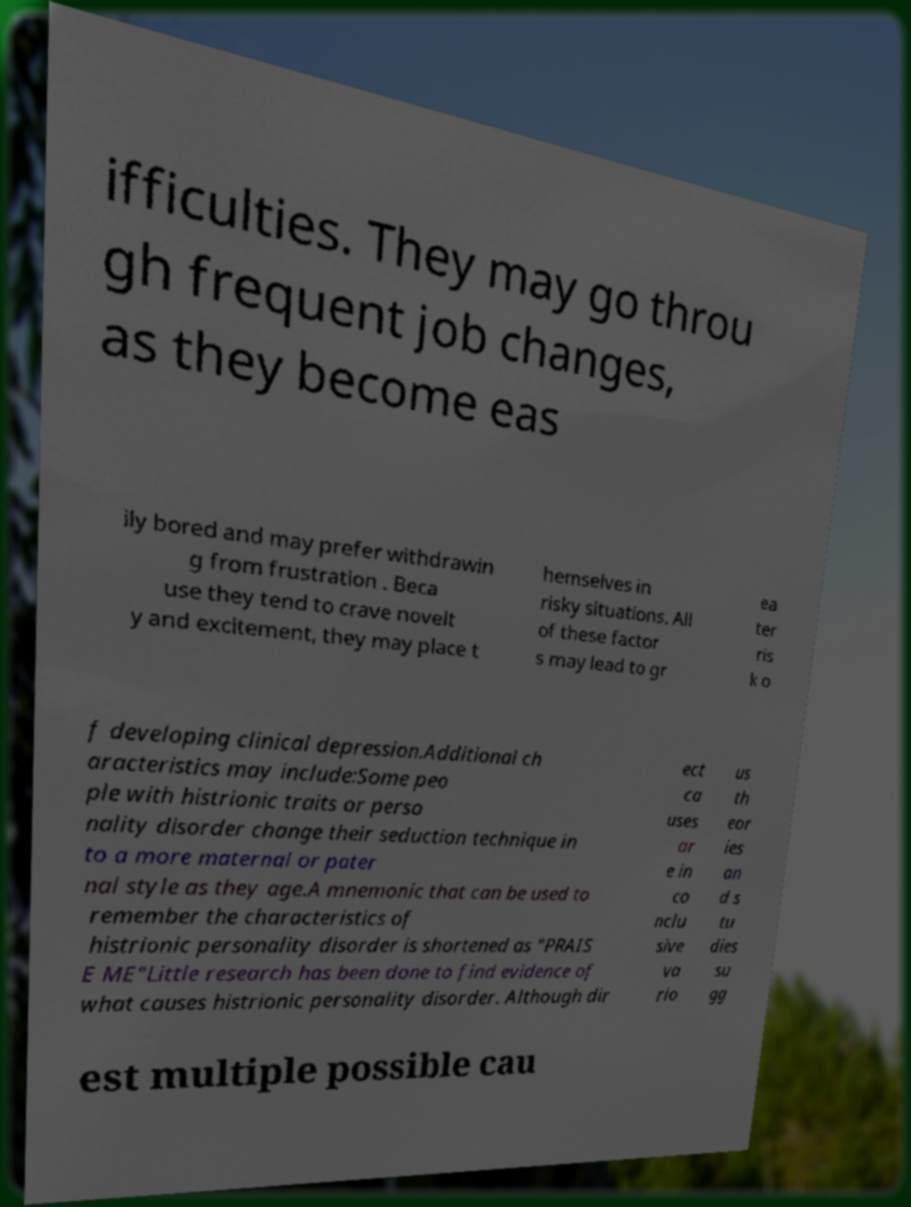Can you read and provide the text displayed in the image?This photo seems to have some interesting text. Can you extract and type it out for me? ifficulties. They may go throu gh frequent job changes, as they become eas ily bored and may prefer withdrawin g from frustration . Beca use they tend to crave novelt y and excitement, they may place t hemselves in risky situations. All of these factor s may lead to gr ea ter ris k o f developing clinical depression.Additional ch aracteristics may include:Some peo ple with histrionic traits or perso nality disorder change their seduction technique in to a more maternal or pater nal style as they age.A mnemonic that can be used to remember the characteristics of histrionic personality disorder is shortened as "PRAIS E ME"Little research has been done to find evidence of what causes histrionic personality disorder. Although dir ect ca uses ar e in co nclu sive va rio us th eor ies an d s tu dies su gg est multiple possible cau 